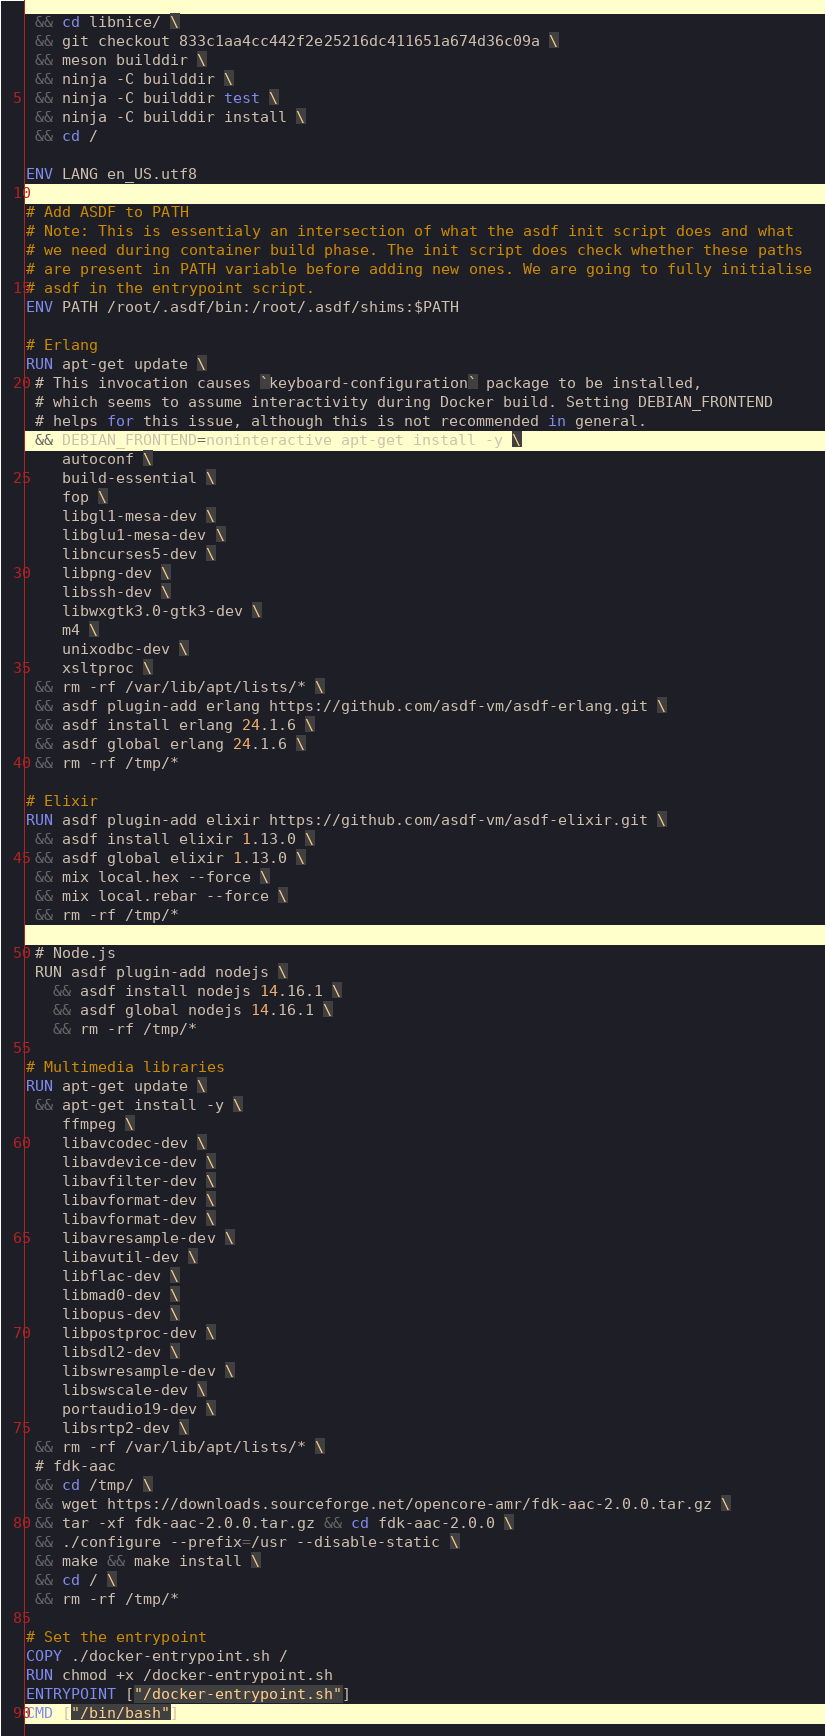Convert code to text. <code><loc_0><loc_0><loc_500><loc_500><_Dockerfile_> && cd libnice/ \
 && git checkout 833c1aa4cc442f2e25216dc411651a674d36c09a \
 && meson builddir \
 && ninja -C builddir \
 && ninja -C builddir test \
 && ninja -C builddir install \
 && cd /

ENV LANG en_US.utf8

# Add ASDF to PATH
# Note: This is essentialy an intersection of what the asdf init script does and what
# we need during container build phase. The init script does check whether these paths
# are present in PATH variable before adding new ones. We are going to fully initialise
# asdf in the entrypoint script.
ENV PATH /root/.asdf/bin:/root/.asdf/shims:$PATH

# Erlang
RUN apt-get update \
 # This invocation causes `keyboard-configuration` package to be installed,
 # which seems to assume interactivity during Docker build. Setting DEBIAN_FRONTEND
 # helps for this issue, although this is not recommended in general.
 && DEBIAN_FRONTEND=noninteractive apt-get install -y \
    autoconf \
    build-essential \
    fop \
    libgl1-mesa-dev \
    libglu1-mesa-dev \
    libncurses5-dev \
    libpng-dev \
    libssh-dev \
    libwxgtk3.0-gtk3-dev \
    m4 \
    unixodbc-dev \
    xsltproc \
 && rm -rf /var/lib/apt/lists/* \
 && asdf plugin-add erlang https://github.com/asdf-vm/asdf-erlang.git \
 && asdf install erlang 24.1.6 \
 && asdf global erlang 24.1.6 \
 && rm -rf /tmp/*

# Elixir
RUN asdf plugin-add elixir https://github.com/asdf-vm/asdf-elixir.git \
 && asdf install elixir 1.13.0 \
 && asdf global elixir 1.13.0 \
 && mix local.hex --force \
 && mix local.rebar --force \
 && rm -rf /tmp/*
 
 # Node.js
 RUN asdf plugin-add nodejs \
   && asdf install nodejs 14.16.1 \
   && asdf global nodejs 14.16.1 \
   && rm -rf /tmp/*

# Multimedia libraries
RUN apt-get update \
 && apt-get install -y \
    ffmpeg \
    libavcodec-dev \
    libavdevice-dev \
    libavfilter-dev \
    libavformat-dev \
    libavformat-dev \
    libavresample-dev \
    libavutil-dev \
    libflac-dev \
    libmad0-dev \
    libopus-dev \
    libpostproc-dev \
    libsdl2-dev \
    libswresample-dev \
    libswscale-dev \
    portaudio19-dev \
    libsrtp2-dev \
 && rm -rf /var/lib/apt/lists/* \
 # fdk-aac
 && cd /tmp/ \
 && wget https://downloads.sourceforge.net/opencore-amr/fdk-aac-2.0.0.tar.gz \
 && tar -xf fdk-aac-2.0.0.tar.gz && cd fdk-aac-2.0.0 \
 && ./configure --prefix=/usr --disable-static \
 && make && make install \
 && cd / \
 && rm -rf /tmp/*

# Set the entrypoint
COPY ./docker-entrypoint.sh /
RUN chmod +x /docker-entrypoint.sh
ENTRYPOINT ["/docker-entrypoint.sh"]
CMD ["/bin/bash"]
</code> 